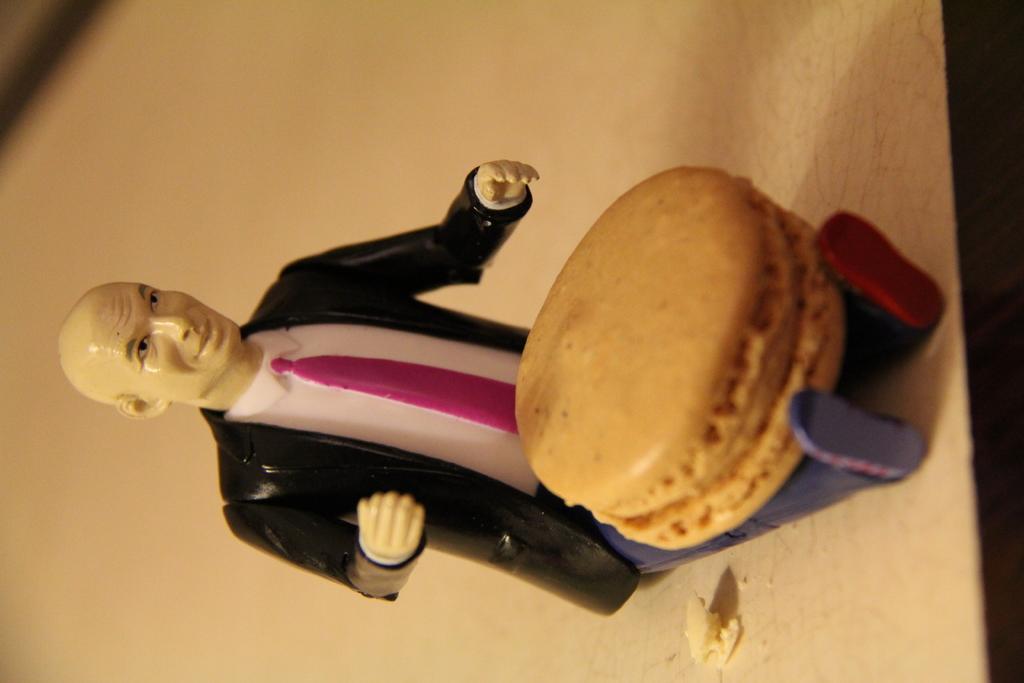Please provide a concise description of this image. In this image we can see a toy and a biscuit on the white color surface. 